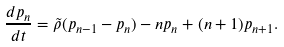Convert formula to latex. <formula><loc_0><loc_0><loc_500><loc_500>\frac { d p _ { n } } { d t } = \tilde { \rho } ( p _ { n - 1 } - p _ { n } ) - n p _ { n } + ( n + 1 ) p _ { n + 1 } .</formula> 